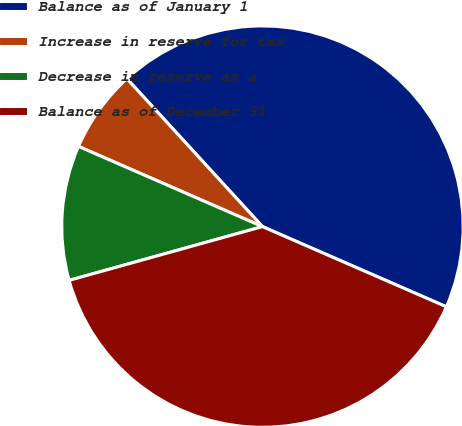Convert chart to OTSL. <chart><loc_0><loc_0><loc_500><loc_500><pie_chart><fcel>Balance as of January 1<fcel>Increase in reserve for tax<fcel>Decrease in reserve as a<fcel>Balance as of December 31<nl><fcel>43.35%<fcel>6.65%<fcel>10.86%<fcel>39.14%<nl></chart> 